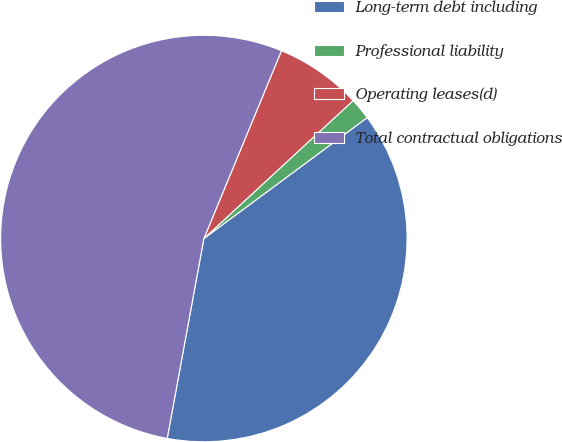<chart> <loc_0><loc_0><loc_500><loc_500><pie_chart><fcel>Long-term debt including<fcel>Professional liability<fcel>Operating leases(d)<fcel>Total contractual obligations<nl><fcel>38.03%<fcel>1.73%<fcel>6.89%<fcel>53.35%<nl></chart> 